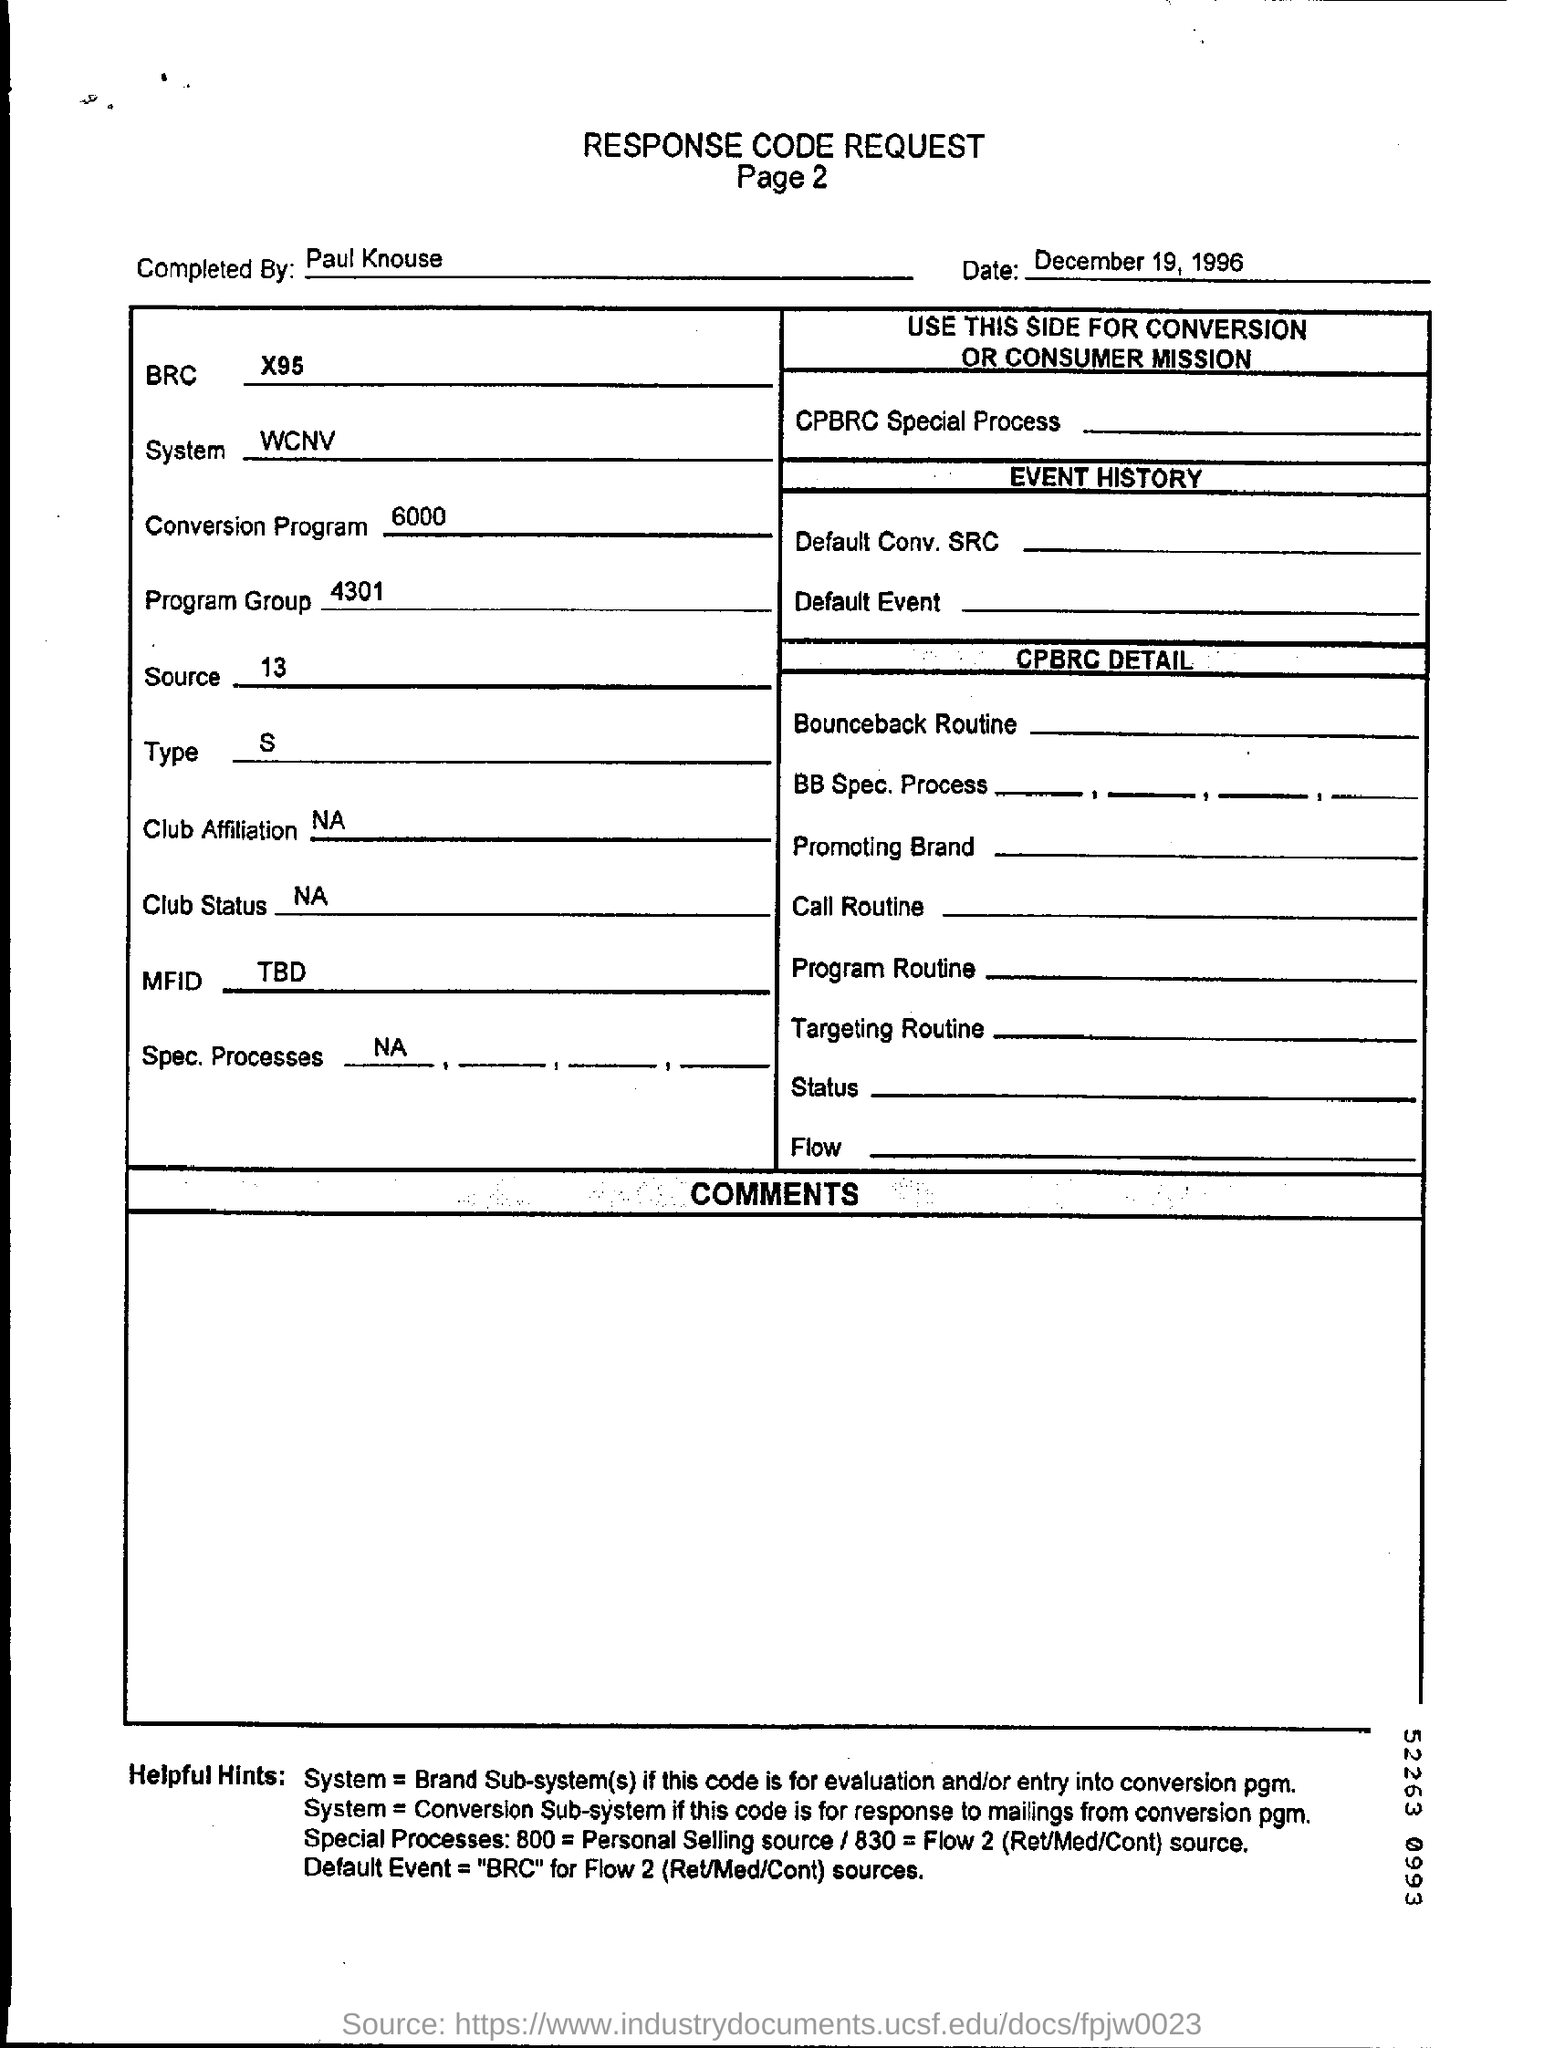By whom is this document completed?
Your answer should be compact. Paul Knouse. What is the date mentioned in the form?
Make the answer very short. December 19, 1996. What is the BRC code mentioned?
Ensure brevity in your answer.  X95. What is the SOURCE number mentioned?
Offer a very short reply. 13. 